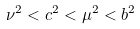<formula> <loc_0><loc_0><loc_500><loc_500>\nu ^ { 2 } < c ^ { 2 } < \mu ^ { 2 } < b ^ { 2 }</formula> 